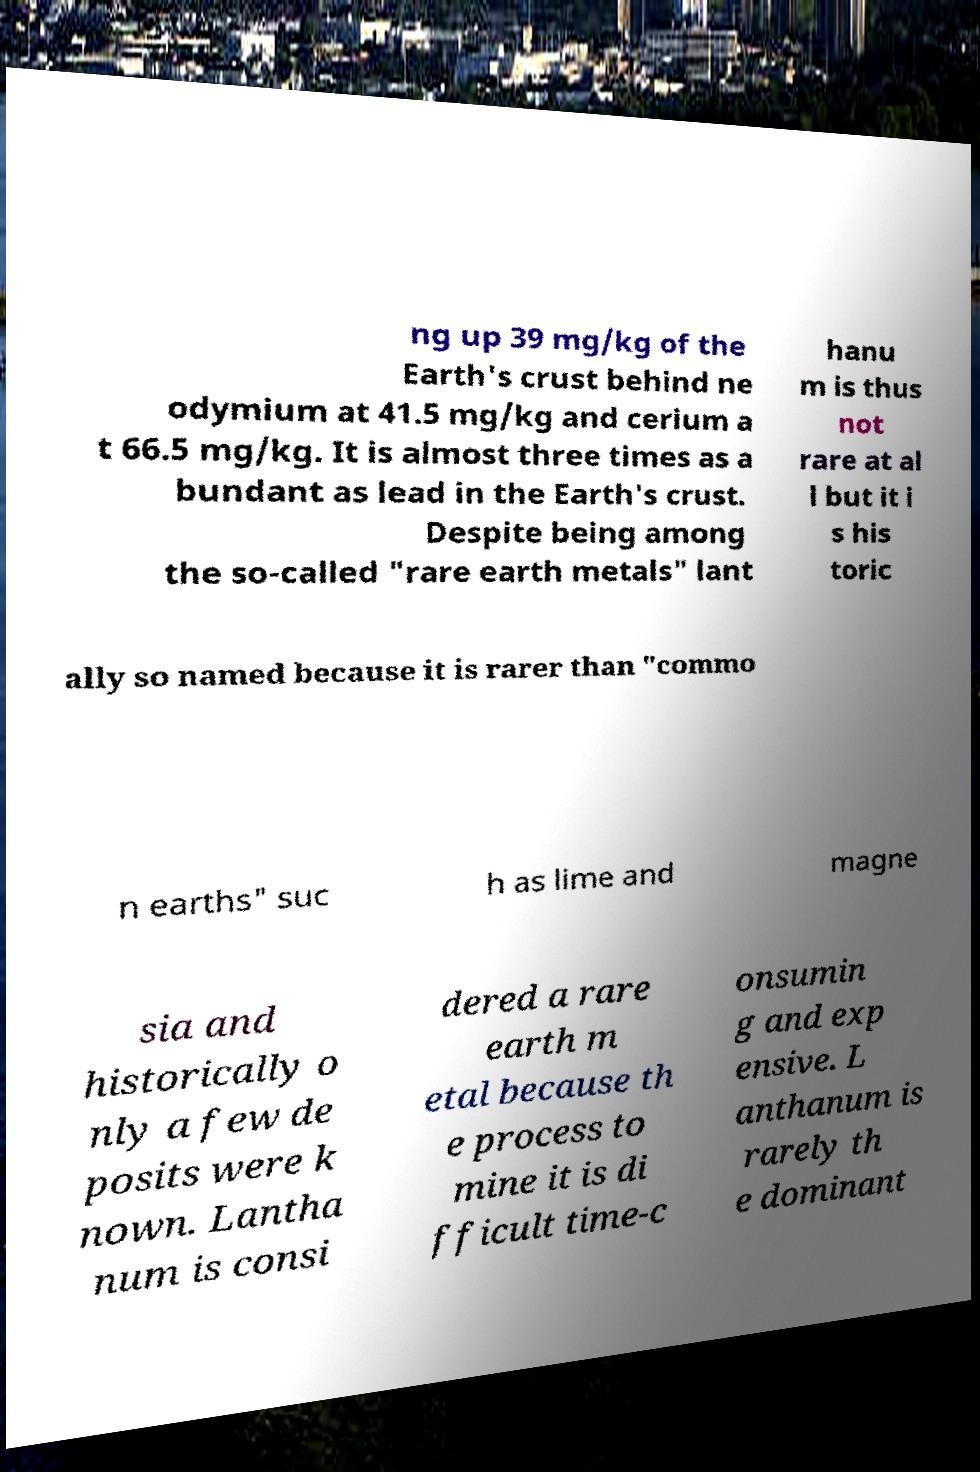Can you accurately transcribe the text from the provided image for me? ng up 39 mg/kg of the Earth's crust behind ne odymium at 41.5 mg/kg and cerium a t 66.5 mg/kg. It is almost three times as a bundant as lead in the Earth's crust. Despite being among the so-called "rare earth metals" lant hanu m is thus not rare at al l but it i s his toric ally so named because it is rarer than "commo n earths" suc h as lime and magne sia and historically o nly a few de posits were k nown. Lantha num is consi dered a rare earth m etal because th e process to mine it is di fficult time-c onsumin g and exp ensive. L anthanum is rarely th e dominant 